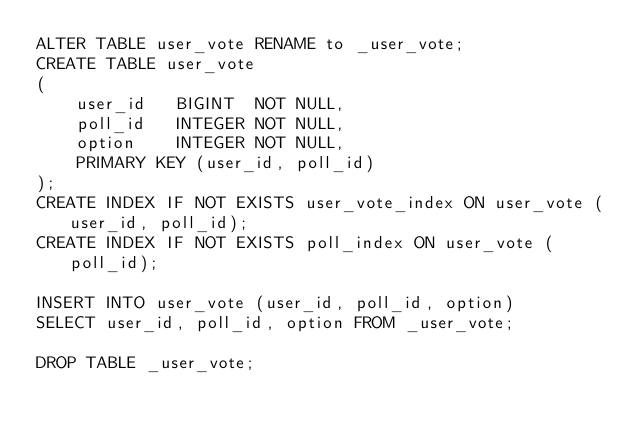Convert code to text. <code><loc_0><loc_0><loc_500><loc_500><_SQL_>ALTER TABLE user_vote RENAME to _user_vote;
CREATE TABLE user_vote
(
    user_id   BIGINT  NOT NULL,
    poll_id   INTEGER NOT NULL,
    option    INTEGER NOT NULL,
    PRIMARY KEY (user_id, poll_id)
);
CREATE INDEX IF NOT EXISTS user_vote_index ON user_vote (user_id, poll_id);
CREATE INDEX IF NOT EXISTS poll_index ON user_vote (poll_id);

INSERT INTO user_vote (user_id, poll_id, option)
SELECT user_id, poll_id, option FROM _user_vote;

DROP TABLE _user_vote;</code> 